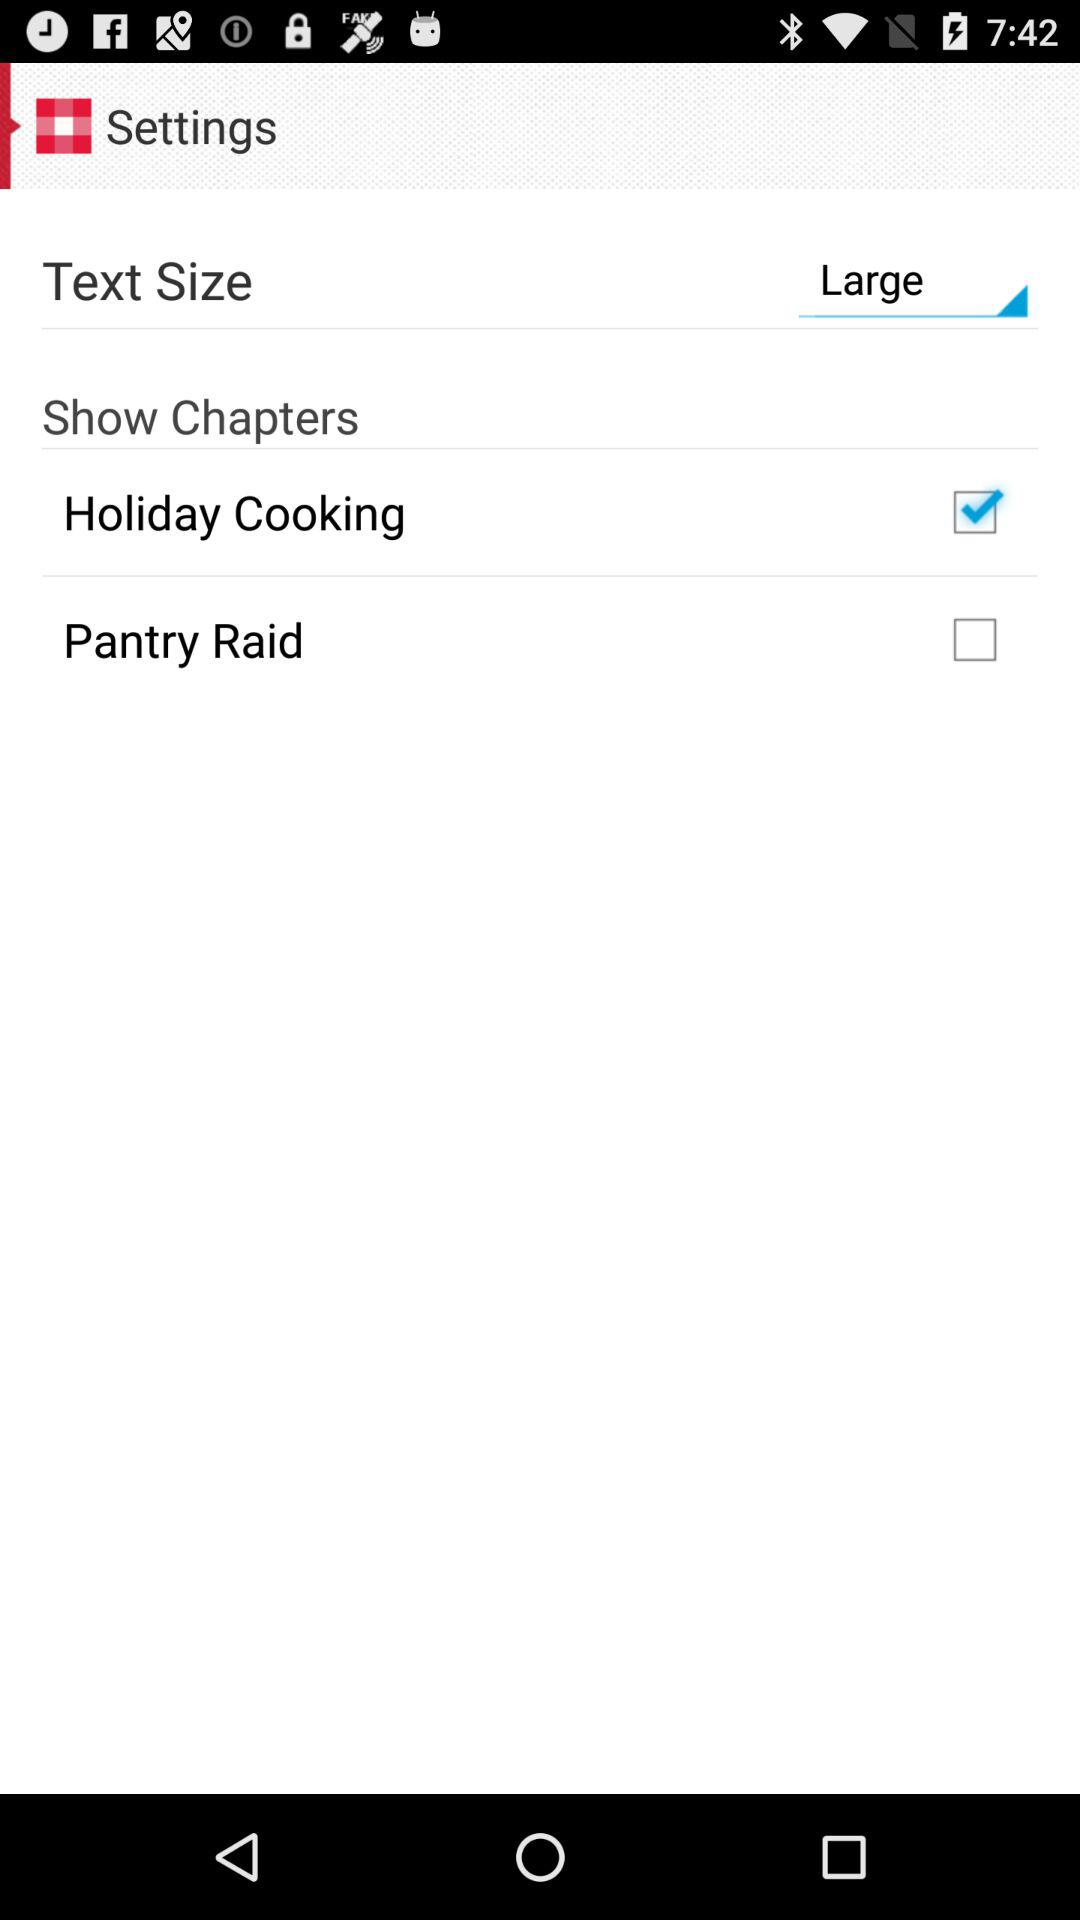Is "Pantry Raid" checked or unchecked? "Pantry Raid" is unchecked. 